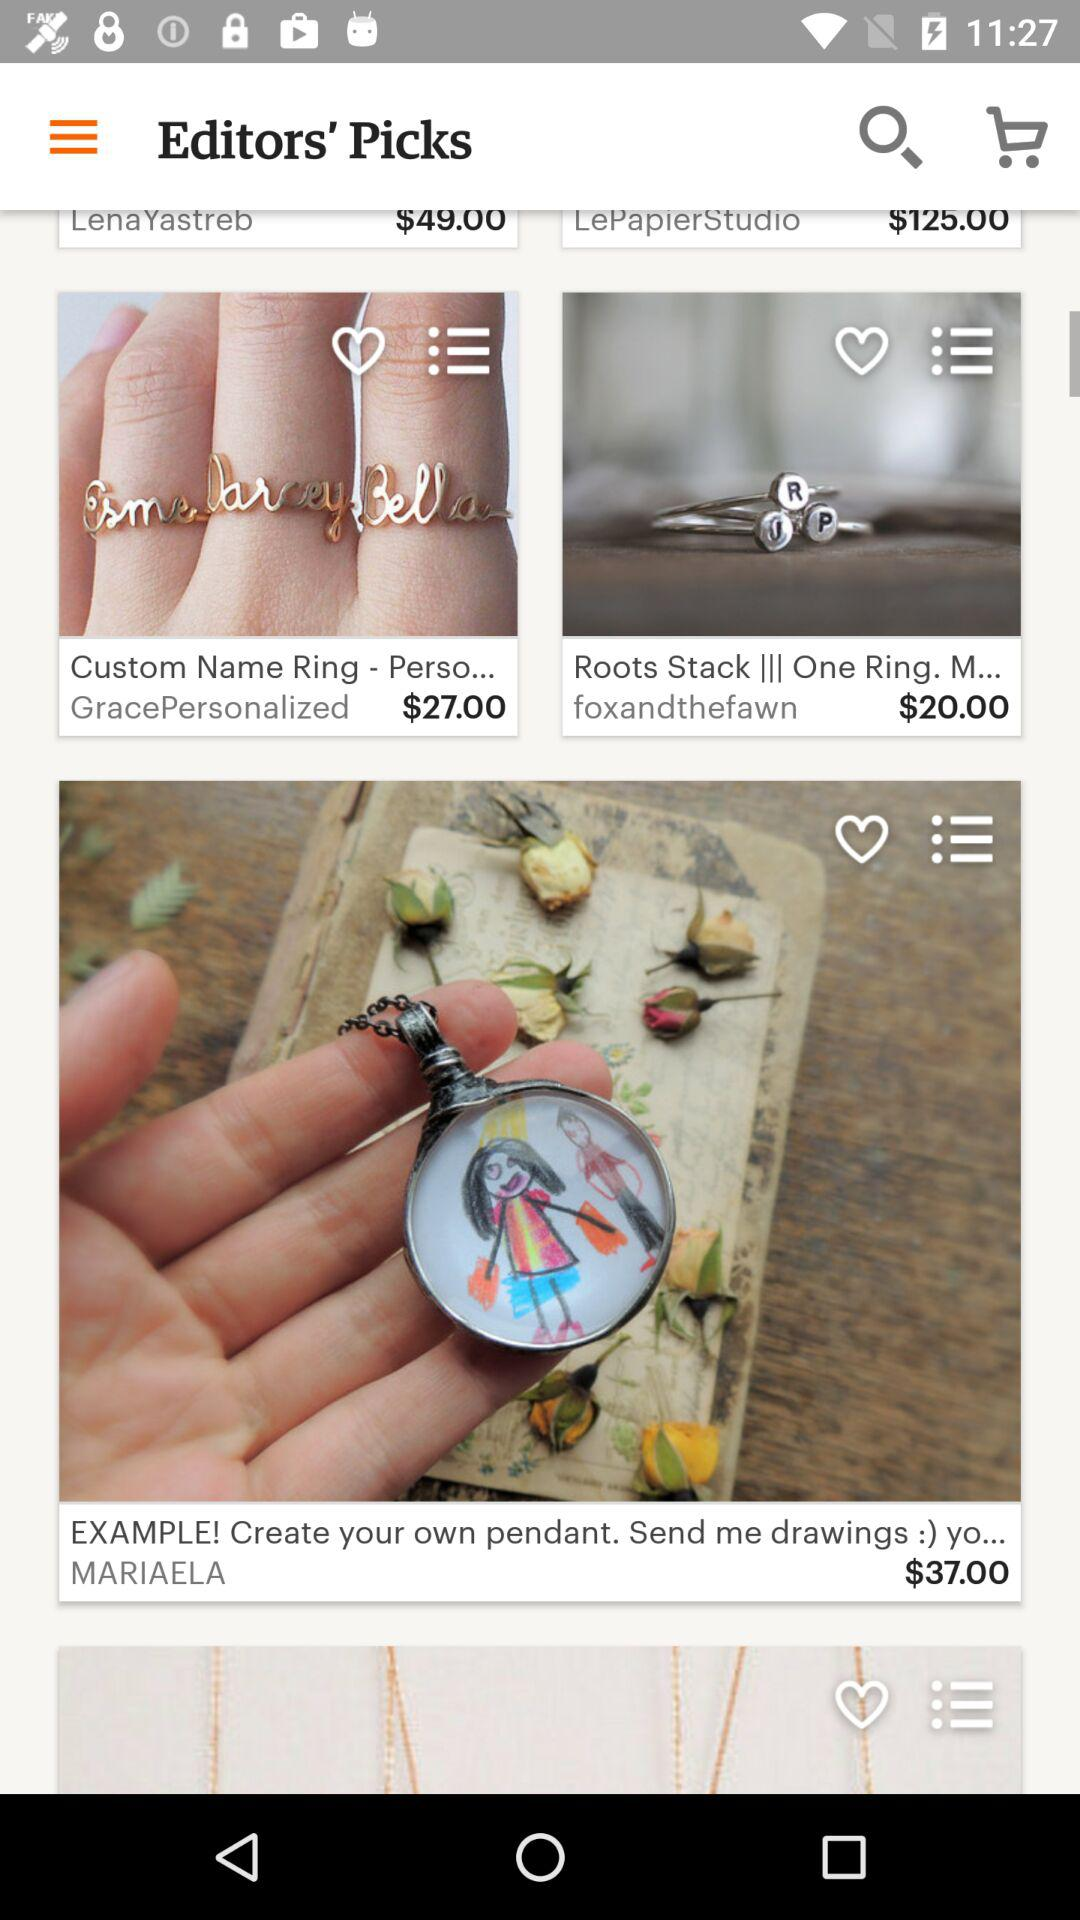What is the price of the custom name ring? The price of the custom name ring is $27.00. 